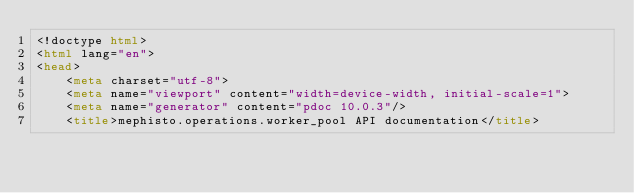<code> <loc_0><loc_0><loc_500><loc_500><_HTML_><!doctype html>
<html lang="en">
<head>
    <meta charset="utf-8">
    <meta name="viewport" content="width=device-width, initial-scale=1">
    <meta name="generator" content="pdoc 10.0.3"/>
    <title>mephisto.operations.worker_pool API documentation</title>
</code> 